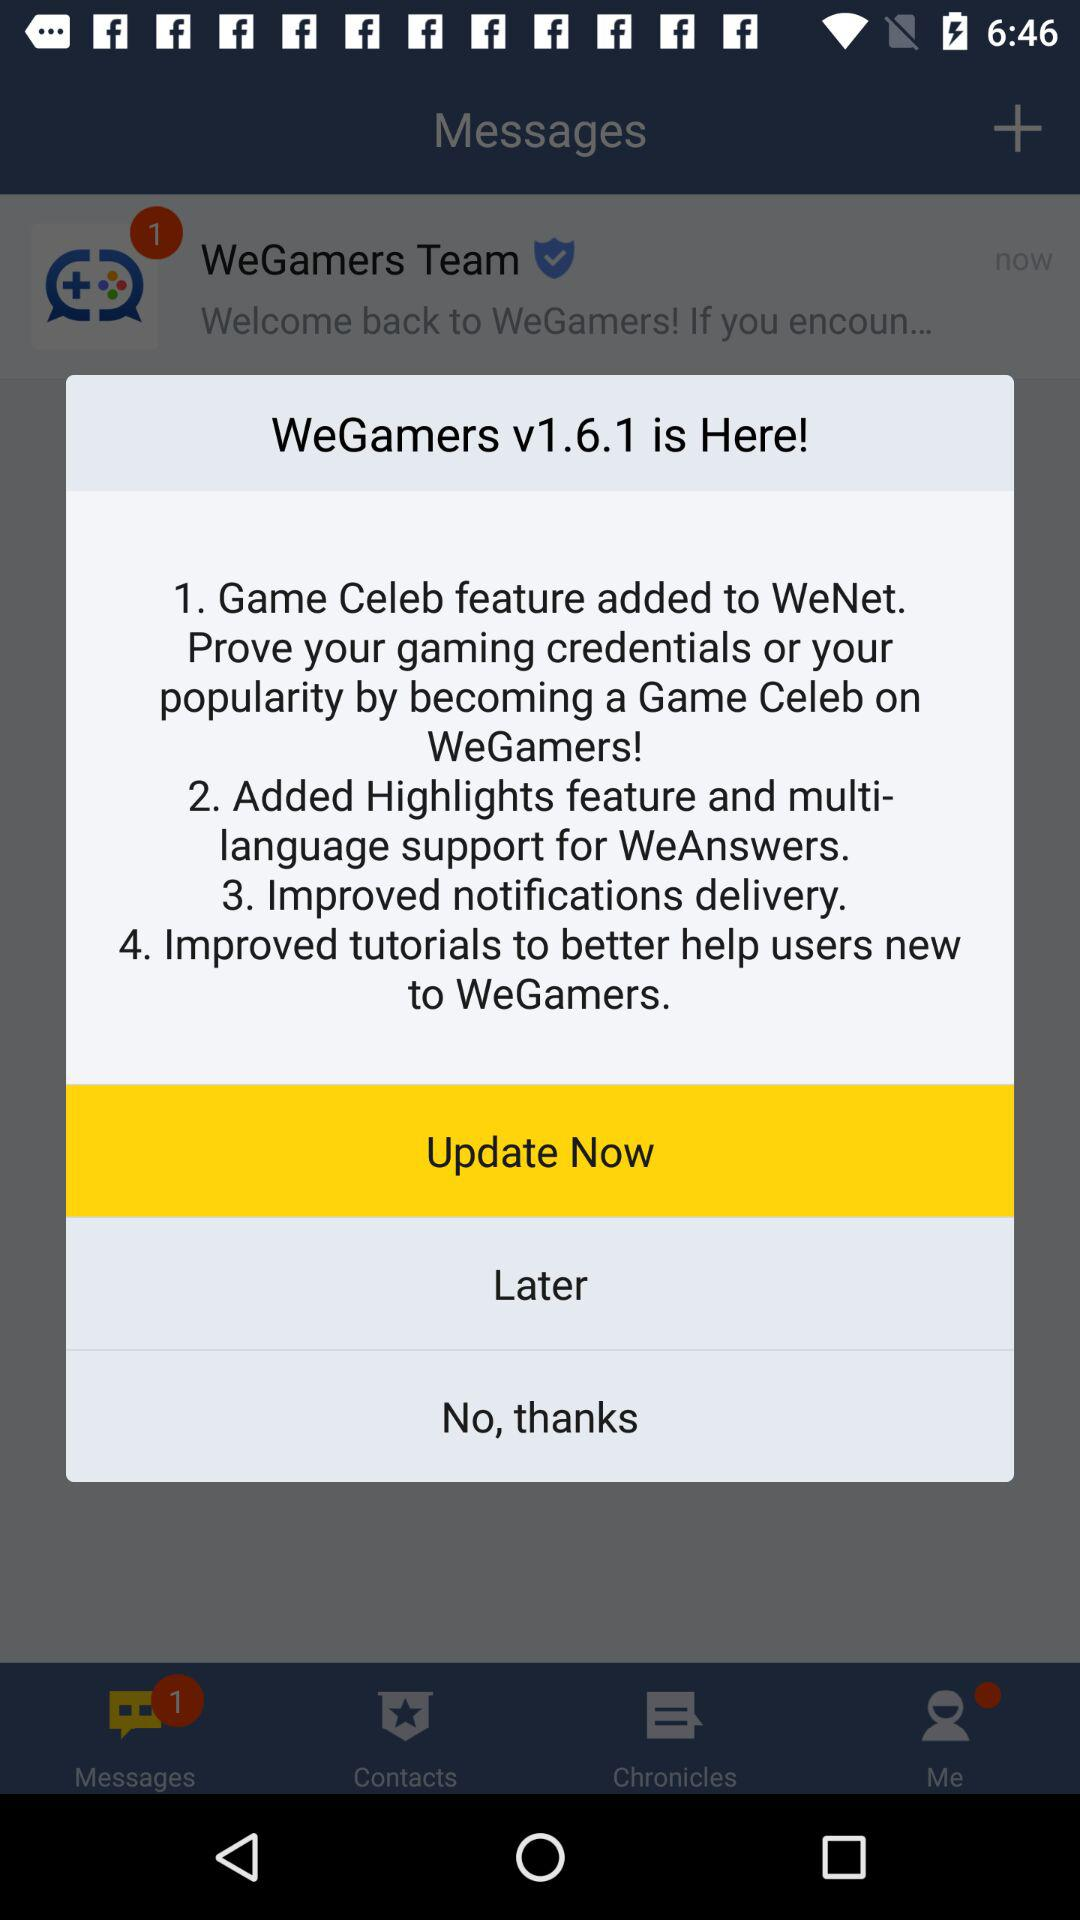Which option has been selected? The selected option is "Update Now". 